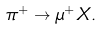<formula> <loc_0><loc_0><loc_500><loc_500>\pi ^ { + } \rightarrow \mu ^ { + } X .</formula> 